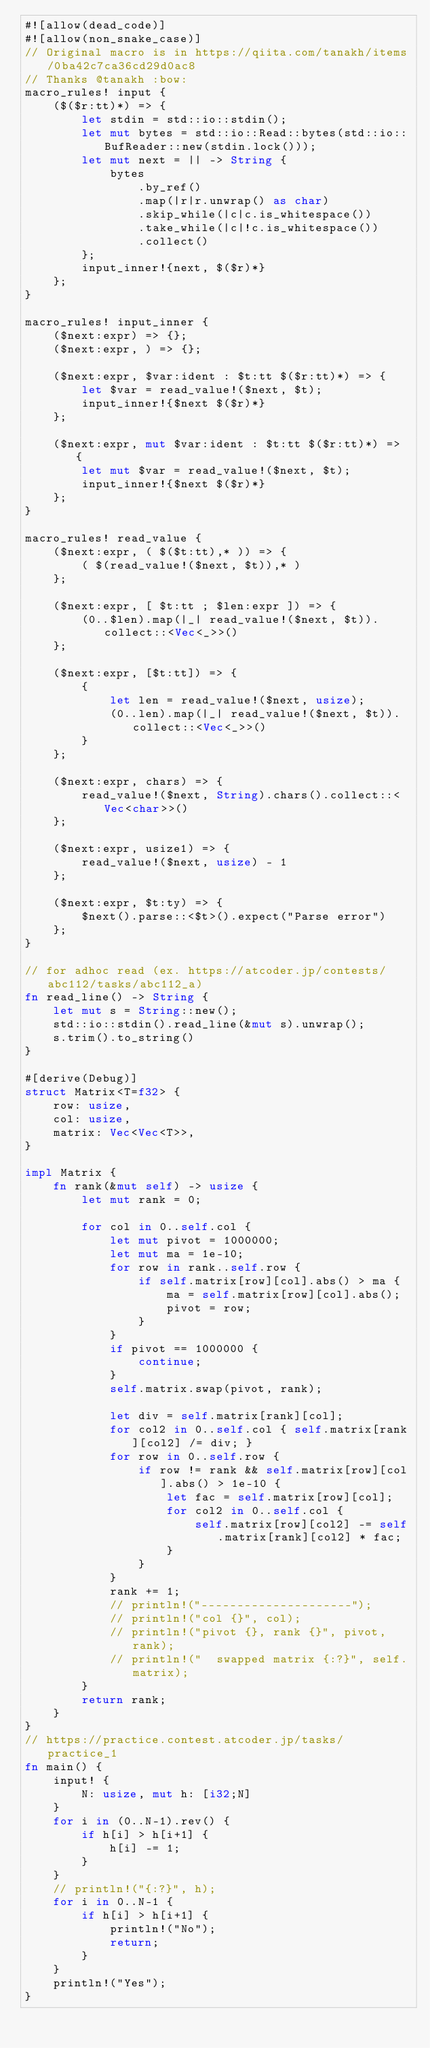Convert code to text. <code><loc_0><loc_0><loc_500><loc_500><_Rust_>#![allow(dead_code)]
#![allow(non_snake_case)]
// Original macro is in https://qiita.com/tanakh/items/0ba42c7ca36cd29d0ac8
// Thanks @tanakh :bow:
macro_rules! input {
    ($($r:tt)*) => {
        let stdin = std::io::stdin();
        let mut bytes = std::io::Read::bytes(std::io::BufReader::new(stdin.lock()));
        let mut next = || -> String {
            bytes
                .by_ref()
                .map(|r|r.unwrap() as char)
                .skip_while(|c|c.is_whitespace())
                .take_while(|c|!c.is_whitespace())
                .collect()
        };
        input_inner!{next, $($r)*}
    };
}
 
macro_rules! input_inner {
    ($next:expr) => {};
    ($next:expr, ) => {};
 
    ($next:expr, $var:ident : $t:tt $($r:tt)*) => {
        let $var = read_value!($next, $t);
        input_inner!{$next $($r)*}
    };
    
    ($next:expr, mut $var:ident : $t:tt $($r:tt)*) => {
        let mut $var = read_value!($next, $t);
        input_inner!{$next $($r)*}
    };
}
 
macro_rules! read_value {
    ($next:expr, ( $($t:tt),* )) => {
        ( $(read_value!($next, $t)),* )
    };
 
    ($next:expr, [ $t:tt ; $len:expr ]) => {
        (0..$len).map(|_| read_value!($next, $t)).collect::<Vec<_>>()
    };

    ($next:expr, [$t:tt]) => {
        {
            let len = read_value!($next, usize);
            (0..len).map(|_| read_value!($next, $t)).collect::<Vec<_>>()
        }
    };
 
    ($next:expr, chars) => {
        read_value!($next, String).chars().collect::<Vec<char>>()
    };
 
    ($next:expr, usize1) => {
        read_value!($next, usize) - 1
    };
 
    ($next:expr, $t:ty) => {
        $next().parse::<$t>().expect("Parse error")
    };
}

// for adhoc read (ex. https://atcoder.jp/contests/abc112/tasks/abc112_a)
fn read_line() -> String {
    let mut s = String::new();
    std::io::stdin().read_line(&mut s).unwrap();
    s.trim().to_string()
}

#[derive(Debug)]
struct Matrix<T=f32> {
    row: usize,
    col: usize,
    matrix: Vec<Vec<T>>,
}

impl Matrix {
    fn rank(&mut self) -> usize {
        let mut rank = 0;

        for col in 0..self.col {
            let mut pivot = 1000000;
            let mut ma = 1e-10;
            for row in rank..self.row {
                if self.matrix[row][col].abs() > ma {
                    ma = self.matrix[row][col].abs();
                    pivot = row;
                }
            }
            if pivot == 1000000 {
                continue;
            }
            self.matrix.swap(pivot, rank);

            let div = self.matrix[rank][col];
            for col2 in 0..self.col { self.matrix[rank][col2] /= div; }
            for row in 0..self.row {
                if row != rank && self.matrix[row][col].abs() > 1e-10 {
                    let fac = self.matrix[row][col];
                    for col2 in 0..self.col {
                        self.matrix[row][col2] -= self.matrix[rank][col2] * fac;
                    }
                }
            }
            rank += 1;
            // println!("---------------------");
            // println!("col {}", col);
            // println!("pivot {}, rank {}", pivot, rank);
            // println!("  swapped matrix {:?}", self.matrix);
        }
        return rank;
    }
}
// https://practice.contest.atcoder.jp/tasks/practice_1
fn main() {
    input! {
        N: usize, mut h: [i32;N]
    }
    for i in (0..N-1).rev() {
        if h[i] > h[i+1] {
            h[i] -= 1;
        }
    }
    // println!("{:?}", h);
    for i in 0..N-1 {
        if h[i] > h[i+1] {
            println!("No");
            return;
        }
    }
    println!("Yes");
}
</code> 